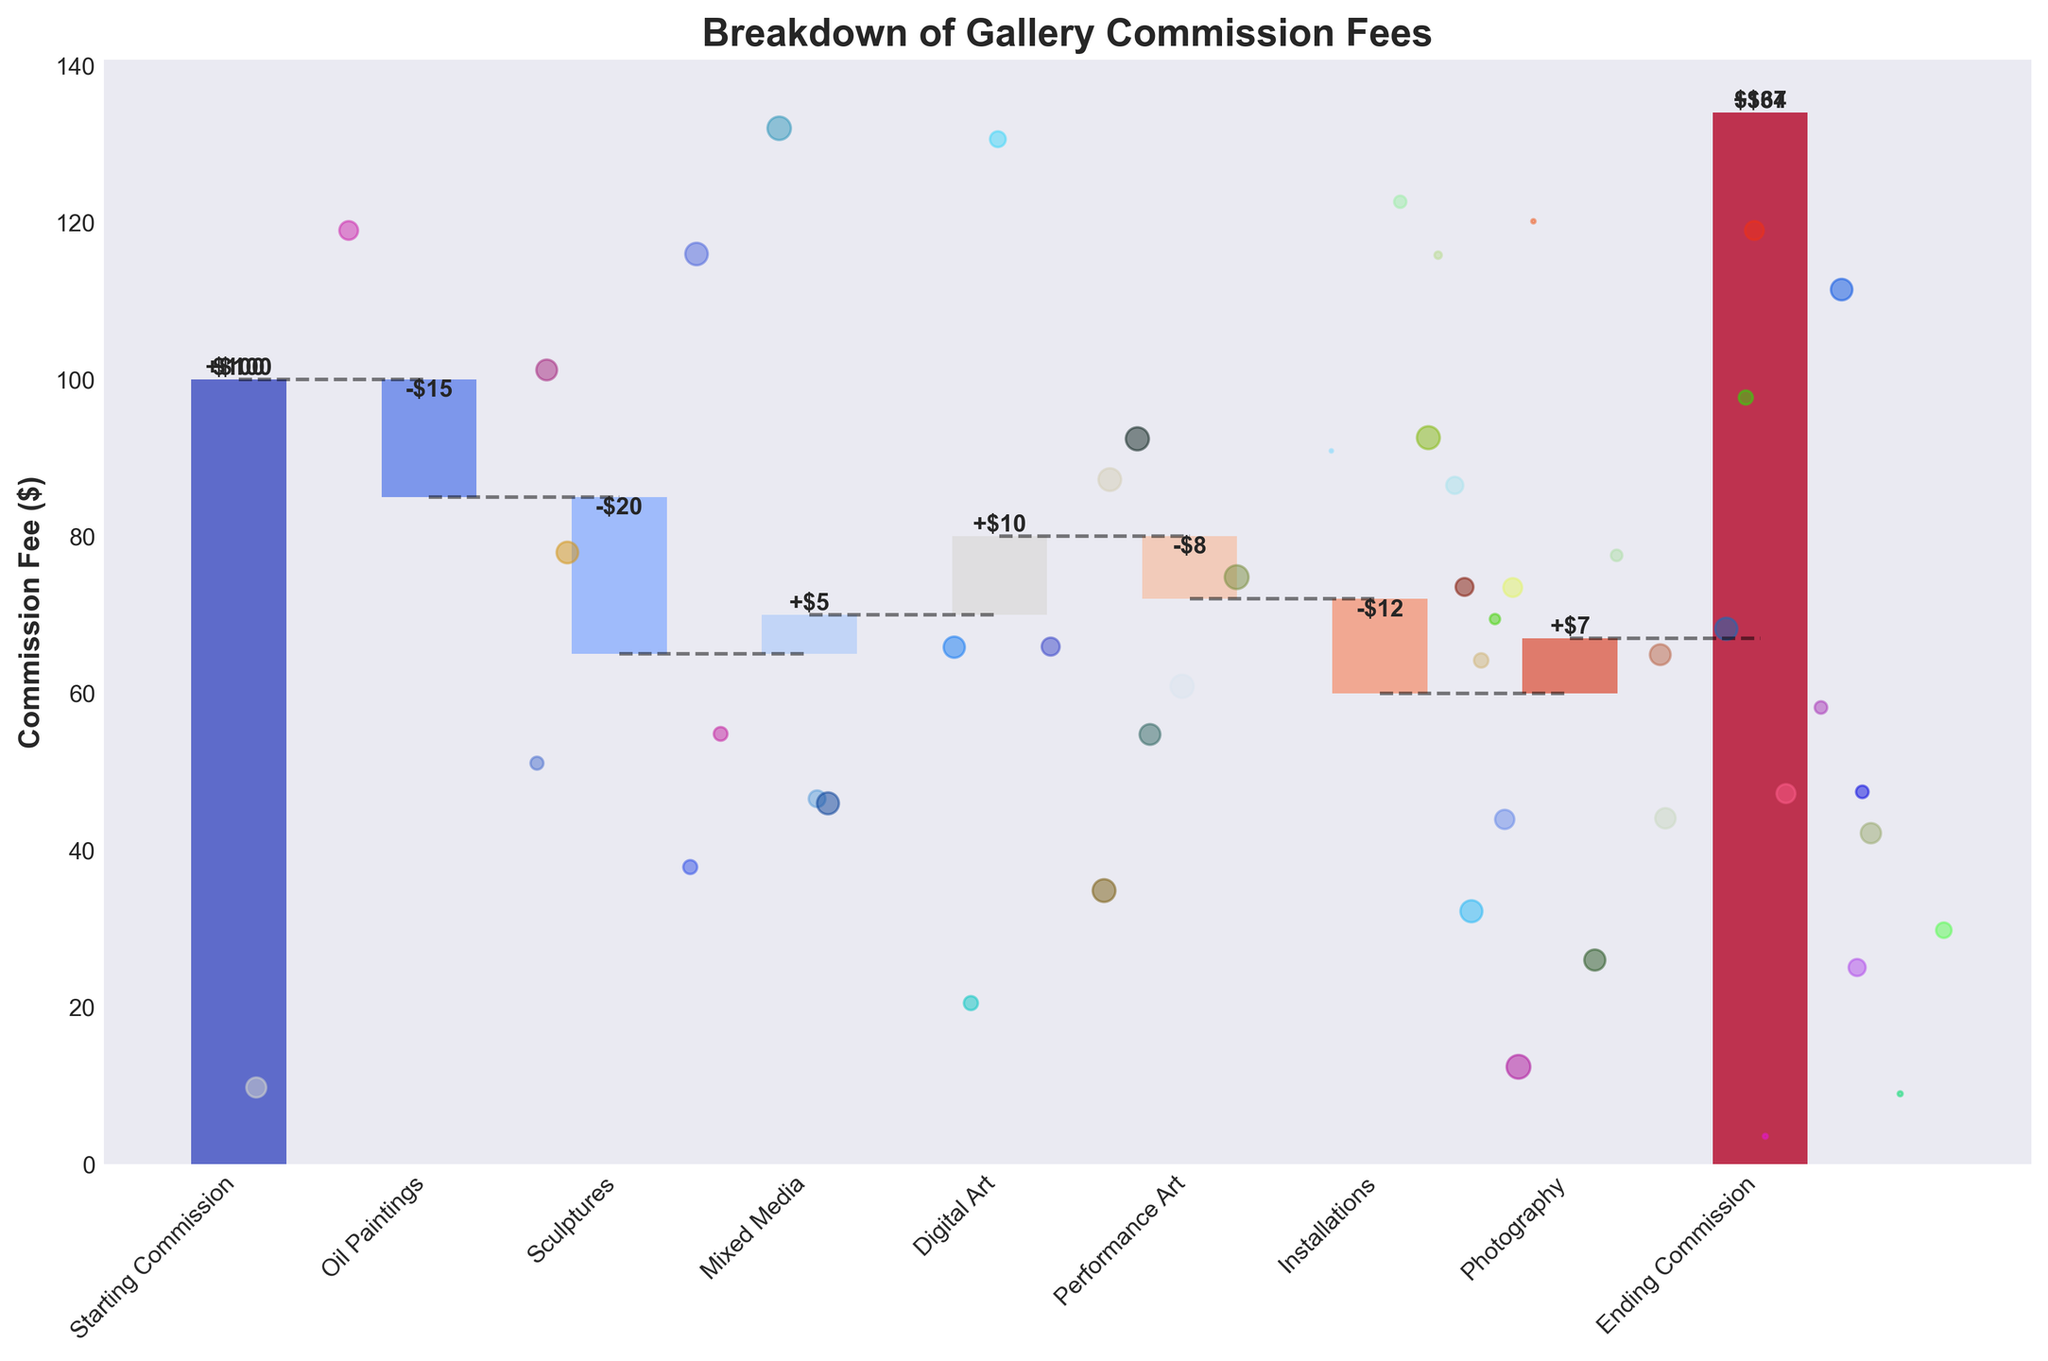what is the title of the figure? The title of the figure is prominently displayed at the top of the chart. It reads "Breakdown of Gallery Commission Fees" in bold.
Answer: Breakdown of Gallery Commission Fees how many categories of artwork are represented in the figure? Each category of artwork is represented as a separate bar on the x-axis. Counting these, we find there are nine categories.
Answer: nine what is the initial value of the starting commission? The initial value of the starting commission is represented by the first bar on the chart, which is noted as $100.
Answer: $100 which type of artwork contributes the largest decrease to the commission fee? We find the largest decrease by looking at the bars with negative values and identifying the one with the greatest drop. Sculptures show the largest decrease at -$20.
Answer: Sculptures which artwork contributes a positive adjustment close to $10 to the commission fee? We look for the bar with a positive value close to $10. Digital Art contributes a +$10 adjustment to the commission fee.
Answer: Digital Art how is the cumulative commission displayed throughout the categories? The cumulative commission is represented by the bars' heights and connected by dashed black lines, showing the progression from one category to the next.
Answer: cumulative bars and dashed lines what is the net change in commission from start to finish? We calculate the net change by subtracting the starting commission ($100) from the ending commission ($67).
Answer: -$33 which categories of artwork contributed positively to the commission fee? The categories with positive values, where the height of the bar increases, are Mixed Media (+$5), Digital Art (+$10), and Photography (+$7).
Answer: Mixed Media, Digital Art, and Photography which category has a contribution opposite to Oil Paintings in terms of sign? Oil Paintings contribute -$15. Looking for a category with a positive value of similar magnitude, we identify Digital Art with +$10.
Answer: Digital Art what is the total decrease in commission fees from Sculpture, Performance Art, and Installations combined? We sum the decreases: Sculptures (-$20) + Performance Art (-$8) + Installations (-$12). The total decrease is -$40.
Answer: -$40 